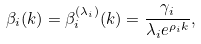<formula> <loc_0><loc_0><loc_500><loc_500>\beta _ { i } ( k ) = \beta ^ { ( \lambda _ { i } ) } _ { i } ( k ) = \frac { \gamma _ { i } } { \lambda _ { i } e ^ { \rho _ { i } k } } ,</formula> 